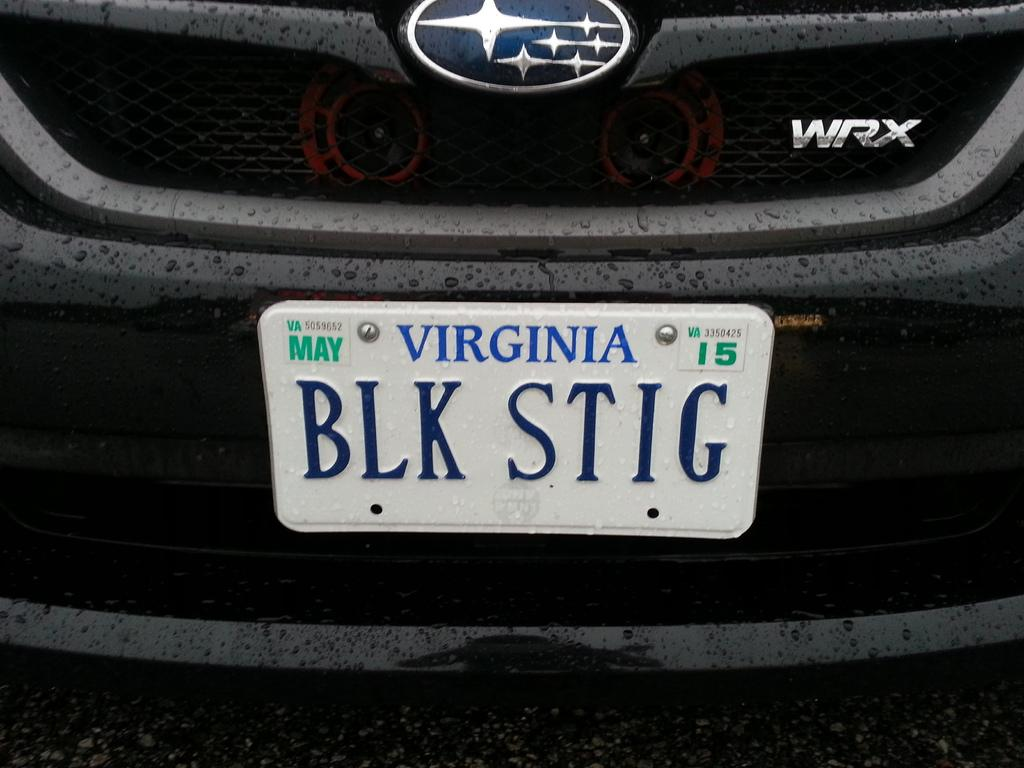<image>
Share a concise interpretation of the image provided. A black car says WRX and has a Virginia license plate. 